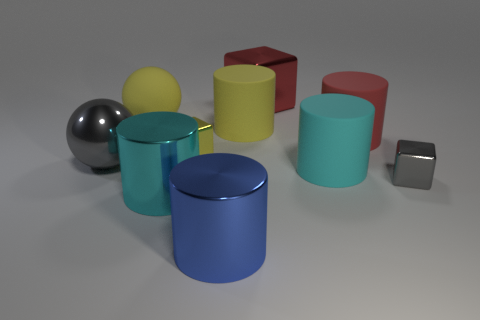Subtract all yellow cylinders. How many cylinders are left? 4 Subtract all red cubes. How many cubes are left? 2 Subtract all cubes. How many objects are left? 7 Subtract all yellow spheres. Subtract all green cylinders. How many spheres are left? 1 Subtract all yellow balls. How many gray blocks are left? 1 Subtract all yellow cylinders. Subtract all large gray balls. How many objects are left? 8 Add 4 small gray shiny things. How many small gray shiny things are left? 5 Add 5 large red shiny objects. How many large red shiny objects exist? 6 Subtract 0 cyan balls. How many objects are left? 10 Subtract 2 blocks. How many blocks are left? 1 